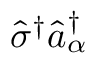<formula> <loc_0><loc_0><loc_500><loc_500>\hat { \sigma } ^ { \dag } \hat { a } _ { \alpha } ^ { \dag }</formula> 